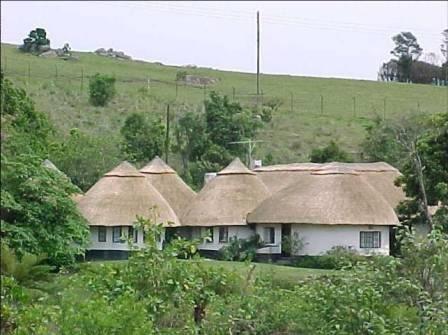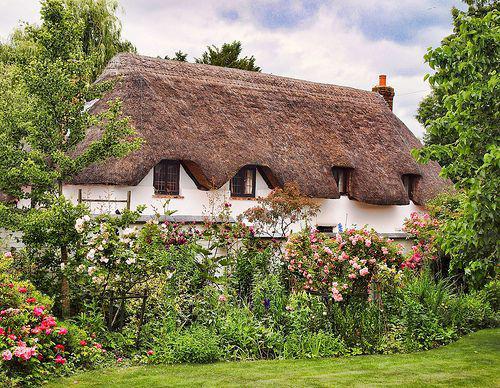The first image is the image on the left, the second image is the image on the right. Considering the images on both sides, is "The walls of one of the thatched houses is covered with a climbing vine, maybe ivy." valid? Answer yes or no. No. The first image is the image on the left, the second image is the image on the right. Given the left and right images, does the statement "There are two chimneys." hold true? Answer yes or no. No. 